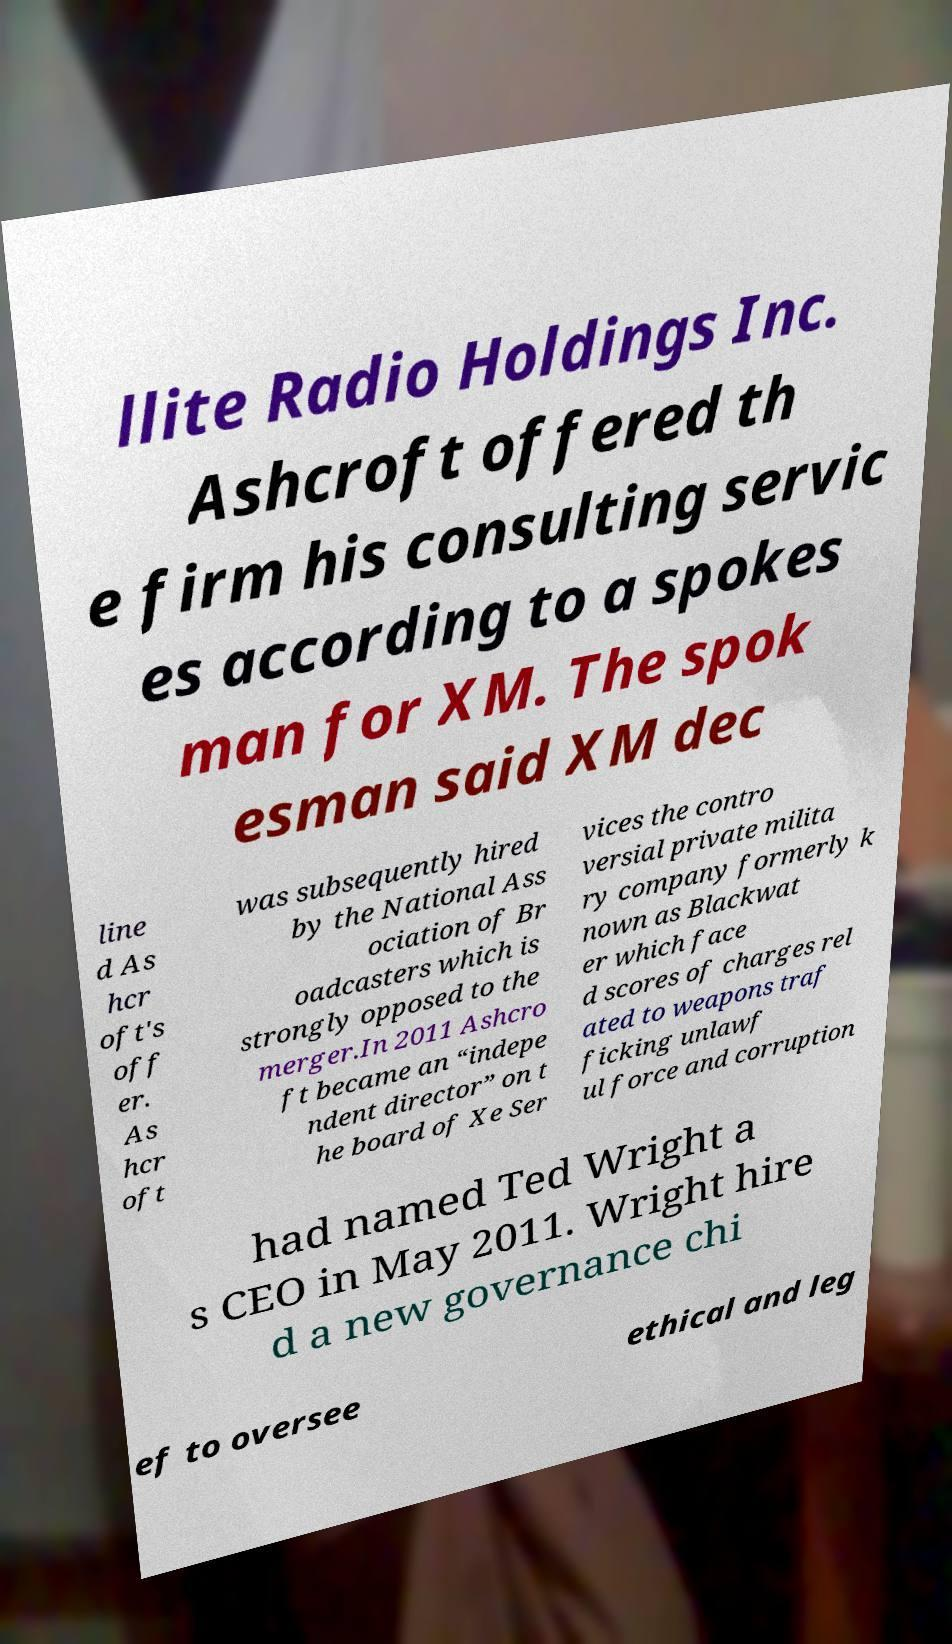Can you read and provide the text displayed in the image?This photo seems to have some interesting text. Can you extract and type it out for me? llite Radio Holdings Inc. Ashcroft offered th e firm his consulting servic es according to a spokes man for XM. The spok esman said XM dec line d As hcr oft's off er. As hcr oft was subsequently hired by the National Ass ociation of Br oadcasters which is strongly opposed to the merger.In 2011 Ashcro ft became an “indepe ndent director” on t he board of Xe Ser vices the contro versial private milita ry company formerly k nown as Blackwat er which face d scores of charges rel ated to weapons traf ficking unlawf ul force and corruption had named Ted Wright a s CEO in May 2011. Wright hire d a new governance chi ef to oversee ethical and leg 